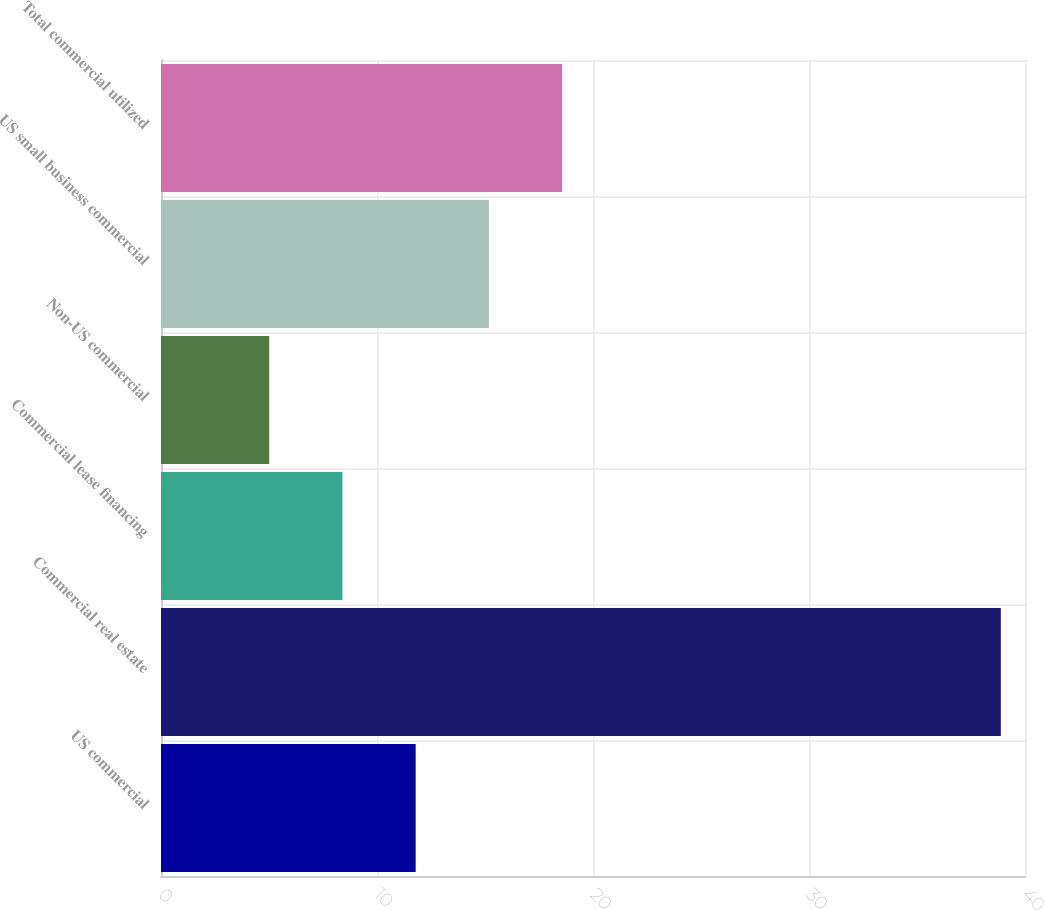Convert chart. <chart><loc_0><loc_0><loc_500><loc_500><bar_chart><fcel>US commercial<fcel>Commercial real estate<fcel>Commercial lease financing<fcel>Non-US commercial<fcel>US small business commercial<fcel>Total commercial utilized<nl><fcel>11.79<fcel>38.88<fcel>8.4<fcel>5.01<fcel>15.18<fcel>18.57<nl></chart> 